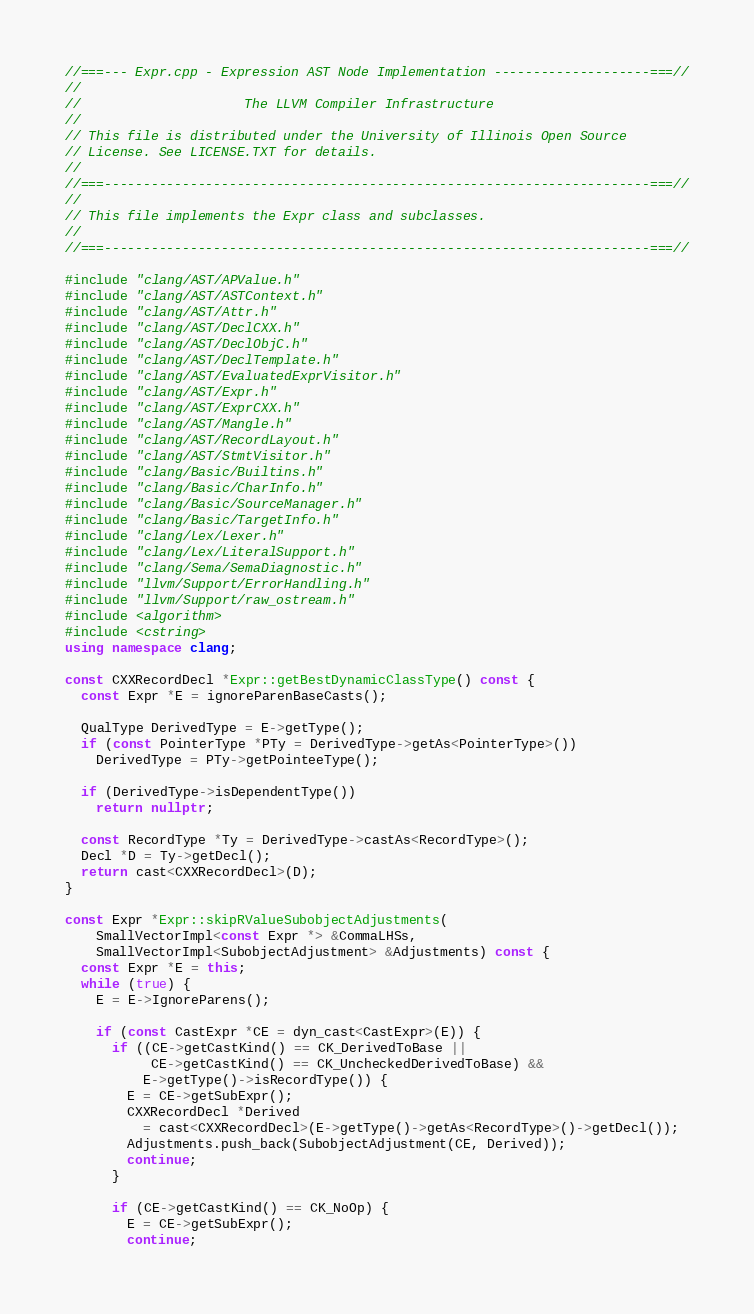Convert code to text. <code><loc_0><loc_0><loc_500><loc_500><_C++_>//===--- Expr.cpp - Expression AST Node Implementation --------------------===//
//
//                     The LLVM Compiler Infrastructure
//
// This file is distributed under the University of Illinois Open Source
// License. See LICENSE.TXT for details.
//
//===----------------------------------------------------------------------===//
//
// This file implements the Expr class and subclasses.
//
//===----------------------------------------------------------------------===//

#include "clang/AST/APValue.h"
#include "clang/AST/ASTContext.h"
#include "clang/AST/Attr.h"
#include "clang/AST/DeclCXX.h"
#include "clang/AST/DeclObjC.h"
#include "clang/AST/DeclTemplate.h"
#include "clang/AST/EvaluatedExprVisitor.h"
#include "clang/AST/Expr.h"
#include "clang/AST/ExprCXX.h"
#include "clang/AST/Mangle.h"
#include "clang/AST/RecordLayout.h"
#include "clang/AST/StmtVisitor.h"
#include "clang/Basic/Builtins.h"
#include "clang/Basic/CharInfo.h"
#include "clang/Basic/SourceManager.h"
#include "clang/Basic/TargetInfo.h"
#include "clang/Lex/Lexer.h"
#include "clang/Lex/LiteralSupport.h"
#include "clang/Sema/SemaDiagnostic.h"
#include "llvm/Support/ErrorHandling.h"
#include "llvm/Support/raw_ostream.h"
#include <algorithm>
#include <cstring>
using namespace clang;

const CXXRecordDecl *Expr::getBestDynamicClassType() const {
  const Expr *E = ignoreParenBaseCasts();

  QualType DerivedType = E->getType();
  if (const PointerType *PTy = DerivedType->getAs<PointerType>())
    DerivedType = PTy->getPointeeType();

  if (DerivedType->isDependentType())
    return nullptr;

  const RecordType *Ty = DerivedType->castAs<RecordType>();
  Decl *D = Ty->getDecl();
  return cast<CXXRecordDecl>(D);
}

const Expr *Expr::skipRValueSubobjectAdjustments(
    SmallVectorImpl<const Expr *> &CommaLHSs,
    SmallVectorImpl<SubobjectAdjustment> &Adjustments) const {
  const Expr *E = this;
  while (true) {
    E = E->IgnoreParens();

    if (const CastExpr *CE = dyn_cast<CastExpr>(E)) {
      if ((CE->getCastKind() == CK_DerivedToBase ||
           CE->getCastKind() == CK_UncheckedDerivedToBase) &&
          E->getType()->isRecordType()) {
        E = CE->getSubExpr();
        CXXRecordDecl *Derived
          = cast<CXXRecordDecl>(E->getType()->getAs<RecordType>()->getDecl());
        Adjustments.push_back(SubobjectAdjustment(CE, Derived));
        continue;
      }

      if (CE->getCastKind() == CK_NoOp) {
        E = CE->getSubExpr();
        continue;</code> 